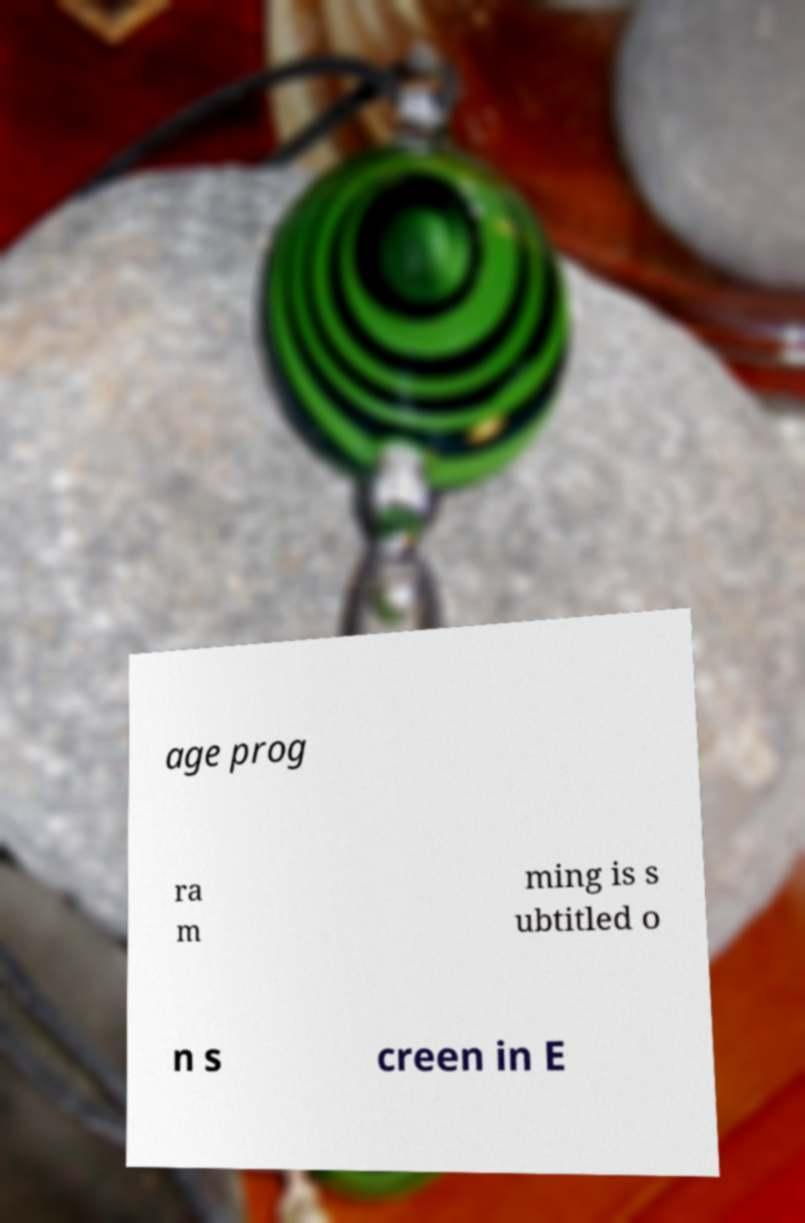For documentation purposes, I need the text within this image transcribed. Could you provide that? age prog ra m ming is s ubtitled o n s creen in E 